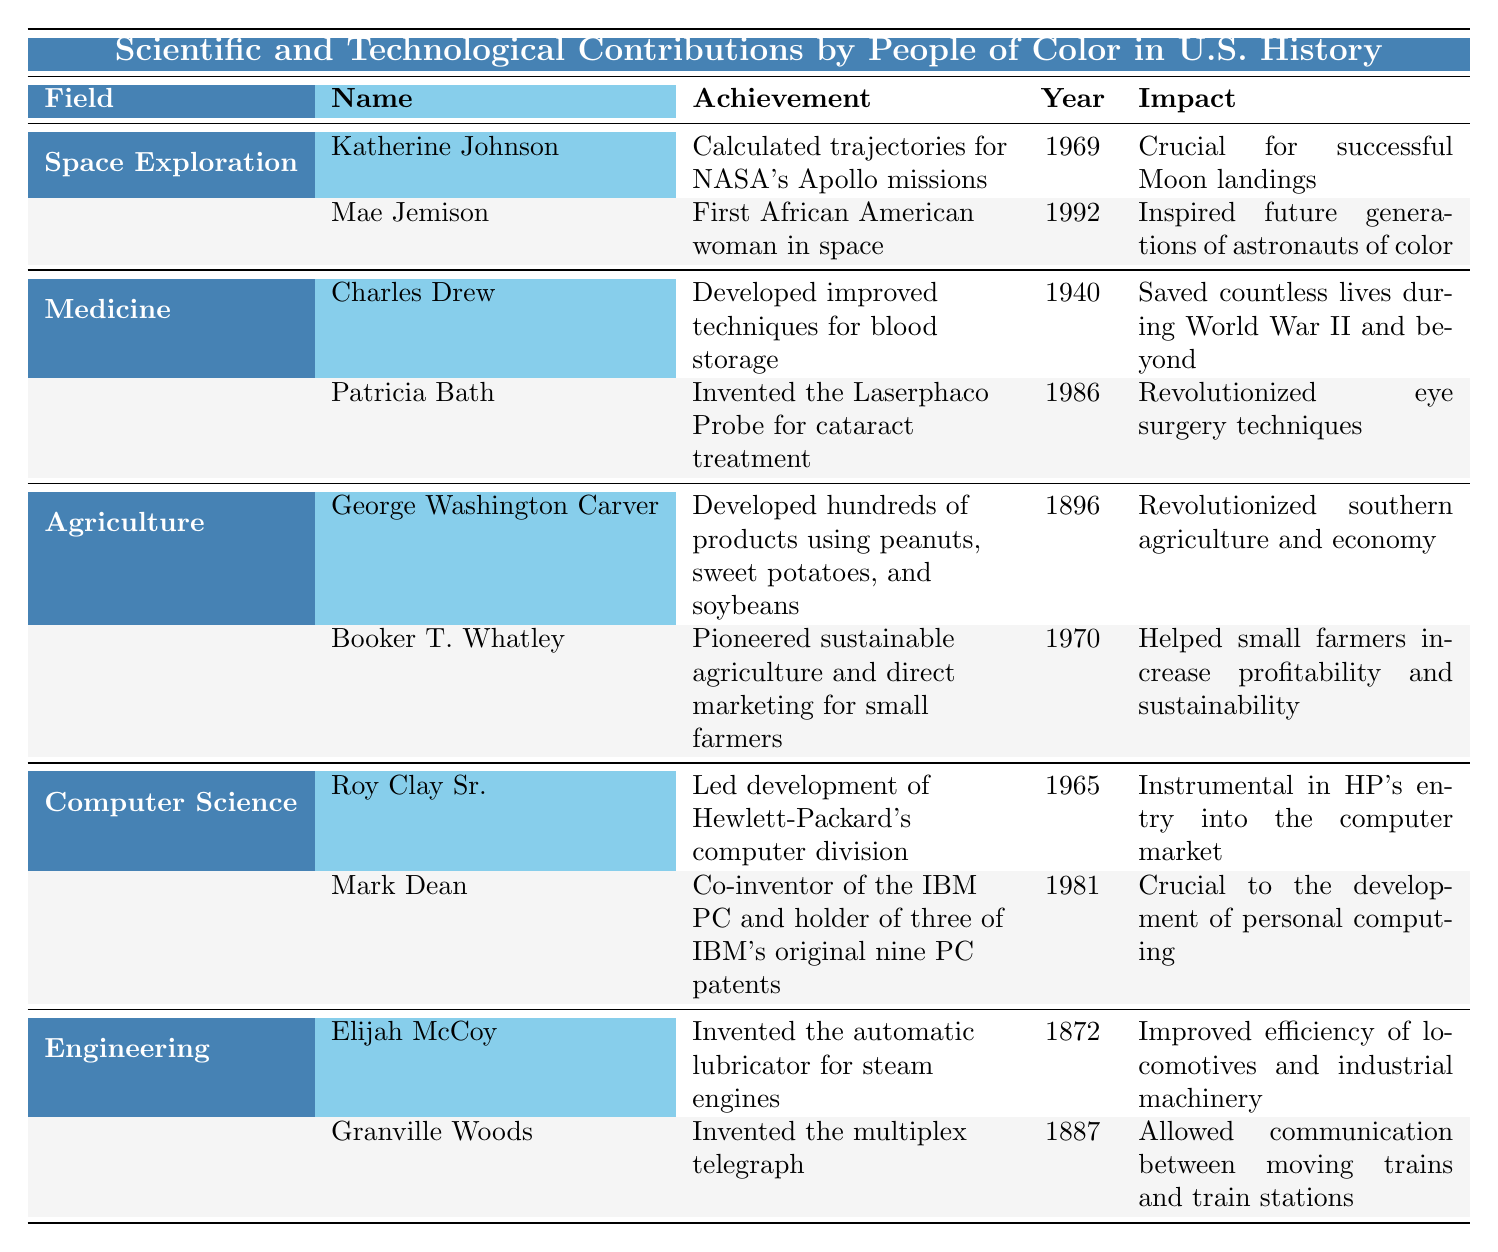What was Katherine Johnson's major achievement? The table lists Katherine Johnson under the field of Space Exploration, stating that her major achievement was calculating trajectories for NASA's Apollo missions in 1969.
Answer: Calculated trajectories for NASA's Apollo missions In which year did Mae Jemison travel to space? The table indicates that Mae Jemison traveled to space in 1992, as highlighted under the Space Exploration field.
Answer: 1992 Who invented the Laserphaco Probe? According to the table, Patricia Bath invented the Laserphaco Probe for cataract treatment, noted under the Medicine field.
Answer: Patricia Bath How many contributions are listed under the field of Engineering? There are two contributions listed under Engineering in the table: one by Elijah McCoy and the other by Granville Woods.
Answer: 2 Which contribution is associated with the year 1986? The table shows that Patricia Bath's invention of the Laserphaco Probe for cataract treatment took place in 1986.
Answer: Patricia Bath's contribution Is George Washington Carver's work more recent than that of Booker T. Whatley? The table lists George Washington Carver's contributions in 1896 and Booker T. Whatley's contributions in 1970, indicating that Whatley's work is more recent.
Answer: No Which field has the earliest listed contribution, and who made it? The earliest listed contribution is in the field of Engineering by Elijah McCoy, who invented the automatic lubricator for steam engines in 1872.
Answer: Engineering; Elijah McCoy What impact did Charles Drew's achievement have during World War II? The table shows that Charles Drew's improved techniques for blood storage saved countless lives during World War II and beyond, emphasizing his significant impact on medicine during that time.
Answer: Saved countless lives Which two fields are represented by inventors who made contributions in the 1960s? The fields represented by inventors in the 1960s are Space Exploration (Katherine Johnson, 1969) and Computer Science (Roy Clay Sr., 1965).
Answer: Space Exploration and Computer Science Who contributed to sustainable agriculture and in what year? The table indicates that Booker T. Whatley pioneered sustainable agriculture in 1970, highlighting his significant contribution to agriculture.
Answer: Booker T. Whatley in 1970 How does the contribution of Mark Dean relate to personal computing? The table indicates that Mark Dean, as a co-inventor of the IBM PC, was crucial to the development of personal computing, emphasizing his role in this technological advancement.
Answer: Crucial to personal computing What is the total number of contributions across all fields in the table? The table lists 10 contributions across various fields (2 each in Space Exploration, Medicine, Agriculture, Computer Science, and Engineering). Adding these gives a total of 10 contributions.
Answer: 10 Which person is recognized for communication technology in trains, and what did they invent? Granville Woods is recognized for his invention of the multiplex telegraph, which allowed communication between moving trains and train stations, as stated under the Engineering field.
Answer: Granville Woods; multiplex telegraph 